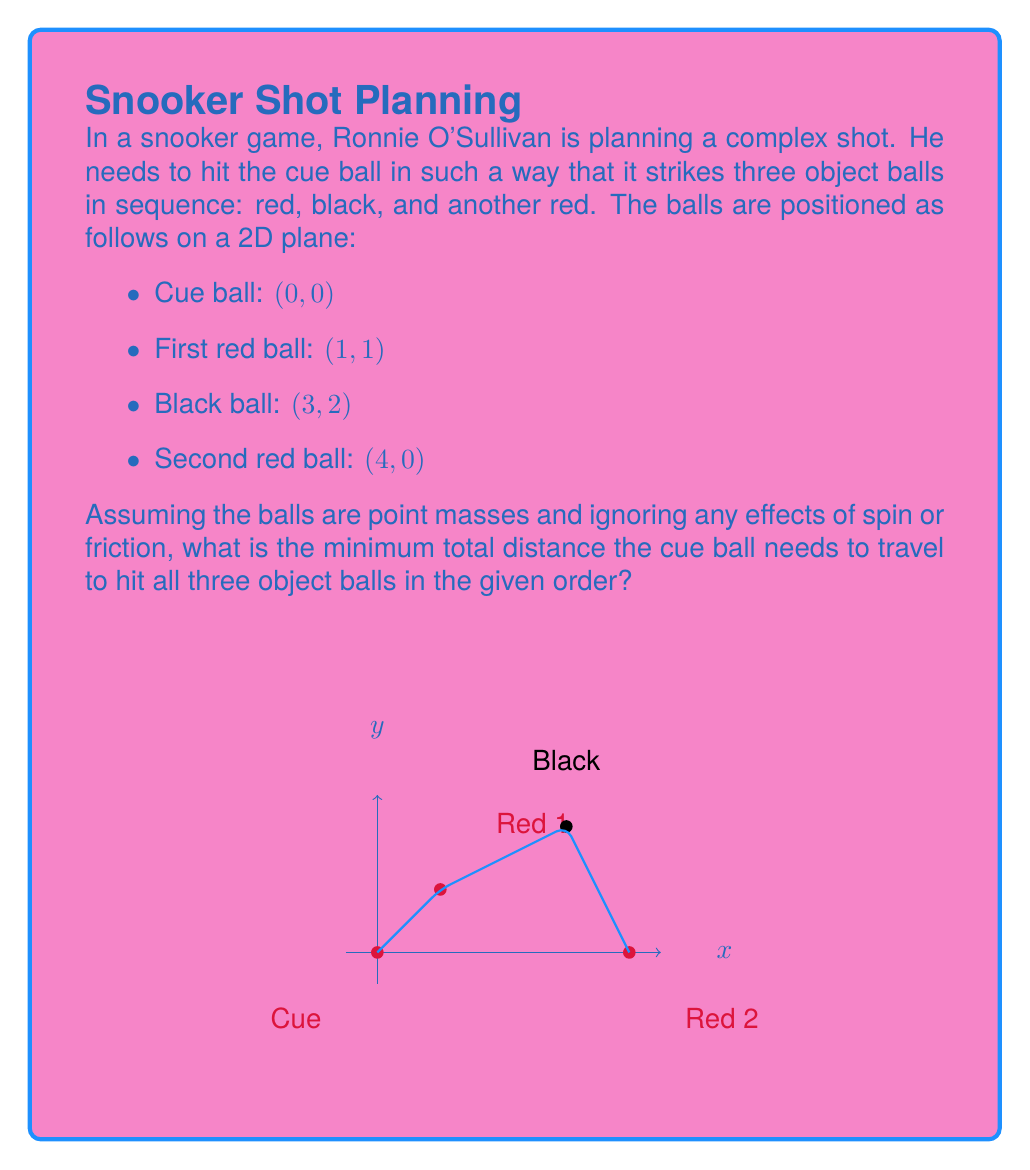Help me with this question. To solve this problem, we need to calculate the total distance of the path that the cue ball takes to hit all three object balls in sequence. The shortest path between two points is always a straight line, so the cue ball will travel in straight lines between each collision.

Let's break this down step-by-step:

1) First, calculate the distance from the cue ball to the first red ball:
   $$d_1 = \sqrt{(1-0)^2 + (1-0)^2} = \sqrt{2}$$

2) Next, calculate the distance from the first red ball to the black ball:
   $$d_2 = \sqrt{(3-1)^2 + (2-1)^2} = \sqrt{5}$$

3) Finally, calculate the distance from the black ball to the second red ball:
   $$d_3 = \sqrt{(4-3)^2 + (0-2)^2} = \sqrt{5}$$

4) The total distance is the sum of these three distances:
   $$d_{total} = d_1 + d_2 + d_3 = \sqrt{2} + \sqrt{5} + \sqrt{5}$$

5) Simplify:
   $$d_{total} = \sqrt{2} + 2\sqrt{5}$$

This path represents the shortest possible route for the cue ball to hit all three object balls in the specified order, given the assumptions stated in the problem.
Answer: The minimum total distance the cue ball needs to travel is $\sqrt{2} + 2\sqrt{5}$ units. 